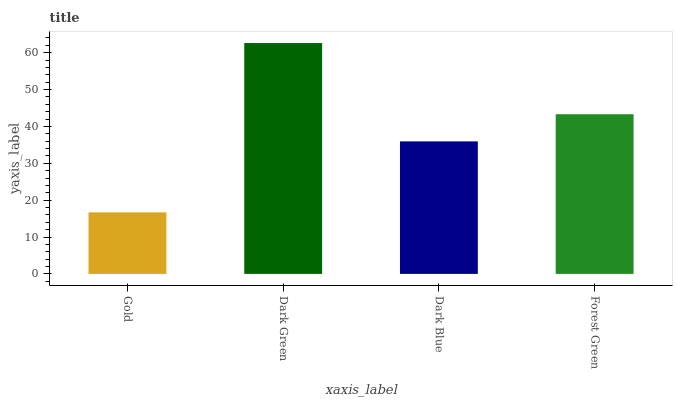Is Gold the minimum?
Answer yes or no. Yes. Is Dark Green the maximum?
Answer yes or no. Yes. Is Dark Blue the minimum?
Answer yes or no. No. Is Dark Blue the maximum?
Answer yes or no. No. Is Dark Green greater than Dark Blue?
Answer yes or no. Yes. Is Dark Blue less than Dark Green?
Answer yes or no. Yes. Is Dark Blue greater than Dark Green?
Answer yes or no. No. Is Dark Green less than Dark Blue?
Answer yes or no. No. Is Forest Green the high median?
Answer yes or no. Yes. Is Dark Blue the low median?
Answer yes or no. Yes. Is Dark Blue the high median?
Answer yes or no. No. Is Gold the low median?
Answer yes or no. No. 